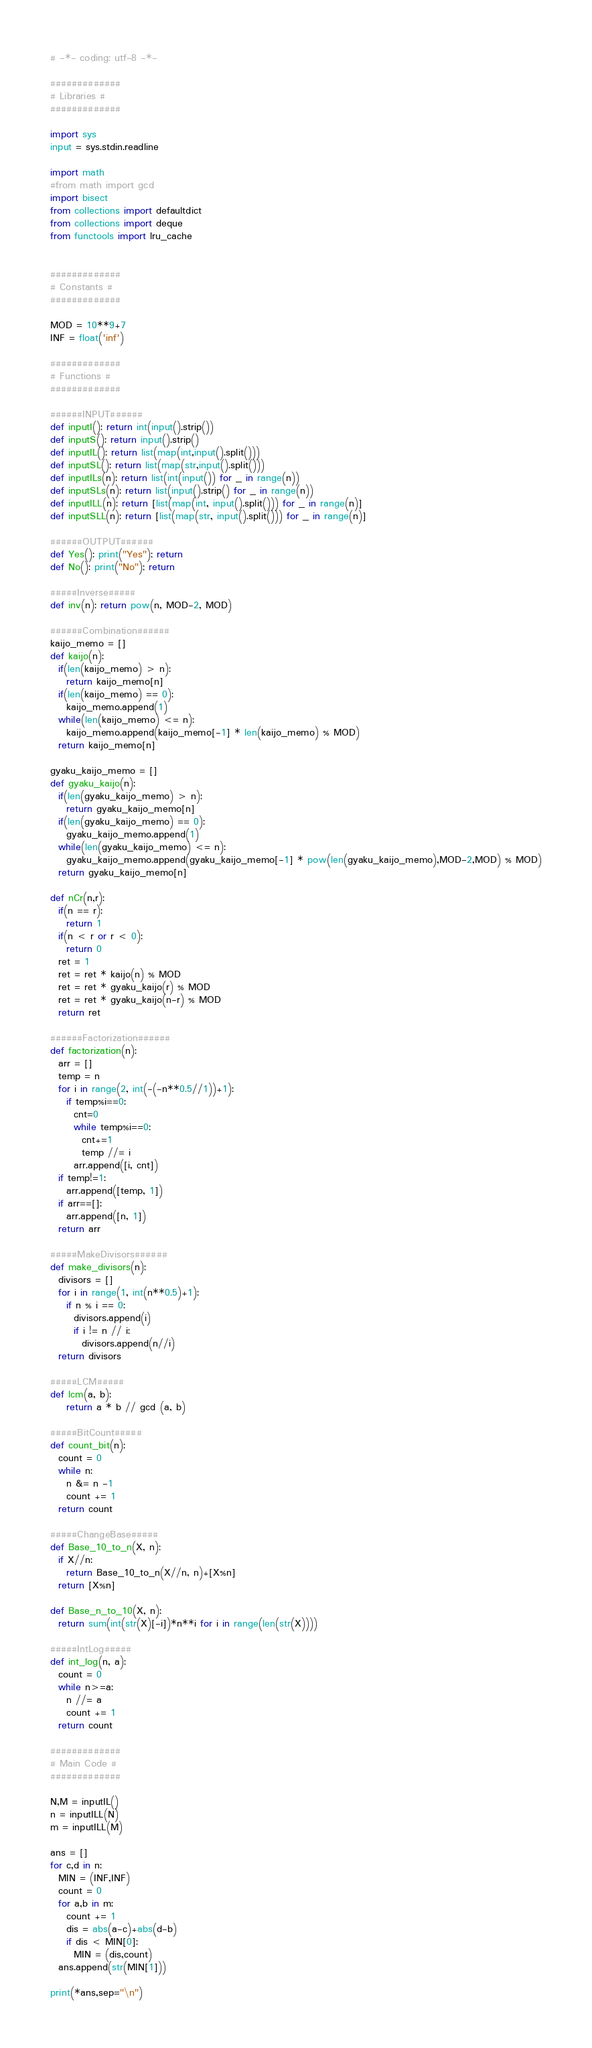Convert code to text. <code><loc_0><loc_0><loc_500><loc_500><_Python_># -*- coding: utf-8 -*-

#############
# Libraries #
#############

import sys
input = sys.stdin.readline

import math
#from math import gcd
import bisect
from collections import defaultdict
from collections import deque
from functools import lru_cache


#############
# Constants #
#############

MOD = 10**9+7
INF = float('inf')

#############
# Functions #
#############

######INPUT######
def inputI(): return int(input().strip())
def inputS(): return input().strip()
def inputIL(): return list(map(int,input().split()))
def inputSL(): return list(map(str,input().split()))
def inputILs(n): return list(int(input()) for _ in range(n))
def inputSLs(n): return list(input().strip() for _ in range(n))
def inputILL(n): return [list(map(int, input().split())) for _ in range(n)]
def inputSLL(n): return [list(map(str, input().split())) for _ in range(n)]

######OUTPUT######
def Yes(): print("Yes"); return
def No(): print("No"); return

#####Inverse#####
def inv(n): return pow(n, MOD-2, MOD)

######Combination######
kaijo_memo = []
def kaijo(n):
  if(len(kaijo_memo) > n):
    return kaijo_memo[n]
  if(len(kaijo_memo) == 0):
    kaijo_memo.append(1)
  while(len(kaijo_memo) <= n):
    kaijo_memo.append(kaijo_memo[-1] * len(kaijo_memo) % MOD)
  return kaijo_memo[n]

gyaku_kaijo_memo = []
def gyaku_kaijo(n):
  if(len(gyaku_kaijo_memo) > n):
    return gyaku_kaijo_memo[n]
  if(len(gyaku_kaijo_memo) == 0):
    gyaku_kaijo_memo.append(1)
  while(len(gyaku_kaijo_memo) <= n):
    gyaku_kaijo_memo.append(gyaku_kaijo_memo[-1] * pow(len(gyaku_kaijo_memo),MOD-2,MOD) % MOD)
  return gyaku_kaijo_memo[n]

def nCr(n,r):
  if(n == r):
    return 1
  if(n < r or r < 0):
    return 0
  ret = 1
  ret = ret * kaijo(n) % MOD
  ret = ret * gyaku_kaijo(r) % MOD
  ret = ret * gyaku_kaijo(n-r) % MOD
  return ret

######Factorization######
def factorization(n):
  arr = []
  temp = n
  for i in range(2, int(-(-n**0.5//1))+1):
    if temp%i==0:
      cnt=0
      while temp%i==0: 
        cnt+=1 
        temp //= i
      arr.append([i, cnt])
  if temp!=1:
    arr.append([temp, 1])
  if arr==[]:
    arr.append([n, 1])
  return arr

#####MakeDivisors######
def make_divisors(n):
  divisors = []
  for i in range(1, int(n**0.5)+1):
    if n % i == 0:
      divisors.append(i)
      if i != n // i: 
        divisors.append(n//i)
  return divisors

#####LCM#####
def lcm(a, b):
    return a * b // gcd (a, b)

#####BitCount#####
def count_bit(n):
  count = 0
  while n:
    n &= n -1
    count += 1
  return count

#####ChangeBase#####
def Base_10_to_n(X, n):
  if X//n:
    return Base_10_to_n(X//n, n)+[X%n]
  return [X%n]

def Base_n_to_10(X, n):
  return sum(int(str(X)[-i])*n**i for i in range(len(str(X))))

#####IntLog#####
def int_log(n, a):
  count = 0
  while n>=a:
    n //= a
    count += 1
  return count

#############
# Main Code #
#############

N,M = inputIL()
n = inputILL(N)
m = inputILL(M)

ans = []
for c,d in n:
  MIN = (INF,INF)
  count = 0
  for a,b in m:
    count += 1
    dis = abs(a-c)+abs(d-b)
    if dis < MIN[0]:
      MIN = (dis,count)
  ans.append(str(MIN[1]))

print(*ans,sep="\n")</code> 